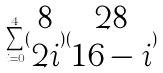Convert formula to latex. <formula><loc_0><loc_0><loc_500><loc_500>\sum _ { i = 0 } ^ { 4 } ( \begin{matrix} 8 \\ 2 i \end{matrix} ) ( \begin{matrix} 2 8 \\ 1 6 - i \end{matrix} )</formula> 